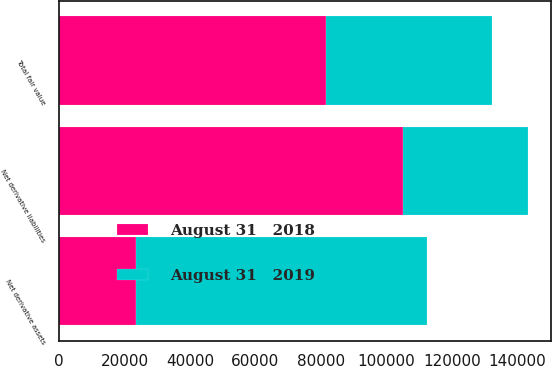Convert chart. <chart><loc_0><loc_0><loc_500><loc_500><stacked_bar_chart><ecel><fcel>Net derivative assets<fcel>Net derivative liabilities<fcel>Total fair value<nl><fcel>August 31   2019<fcel>88811<fcel>37985<fcel>50826<nl><fcel>August 31   2018<fcel>23599<fcel>105144<fcel>81545<nl></chart> 